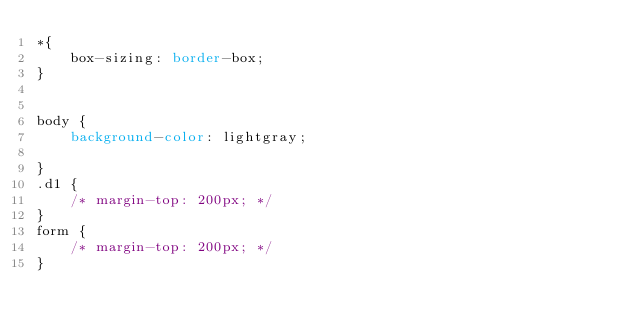Convert code to text. <code><loc_0><loc_0><loc_500><loc_500><_CSS_>*{
    box-sizing: border-box;
}


body {
    background-color: lightgray;

}
.d1 {
    /* margin-top: 200px; */
}
form {
    /* margin-top: 200px; */
}</code> 